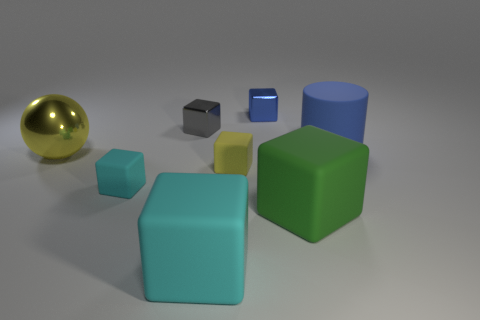Is there a small yellow block made of the same material as the small gray block?
Make the answer very short. No. The other metallic thing that is the same shape as the tiny blue shiny thing is what color?
Your response must be concise. Gray. Is the material of the gray block the same as the block on the left side of the small gray shiny object?
Offer a very short reply. No. There is a tiny matte thing to the right of the small rubber thing that is to the left of the large cyan matte block; what shape is it?
Provide a succinct answer. Cube. Is the size of the blue object that is behind the rubber cylinder the same as the blue matte cylinder?
Give a very brief answer. No. What number of other things are there of the same shape as the large blue matte thing?
Provide a succinct answer. 0. There is a thing to the right of the large green block; is its color the same as the sphere?
Make the answer very short. No. Is there a big cylinder that has the same color as the big shiny thing?
Ensure brevity in your answer.  No. How many big yellow objects are behind the small gray metallic thing?
Your answer should be compact. 0. How many other things are the same size as the green matte block?
Make the answer very short. 3. 